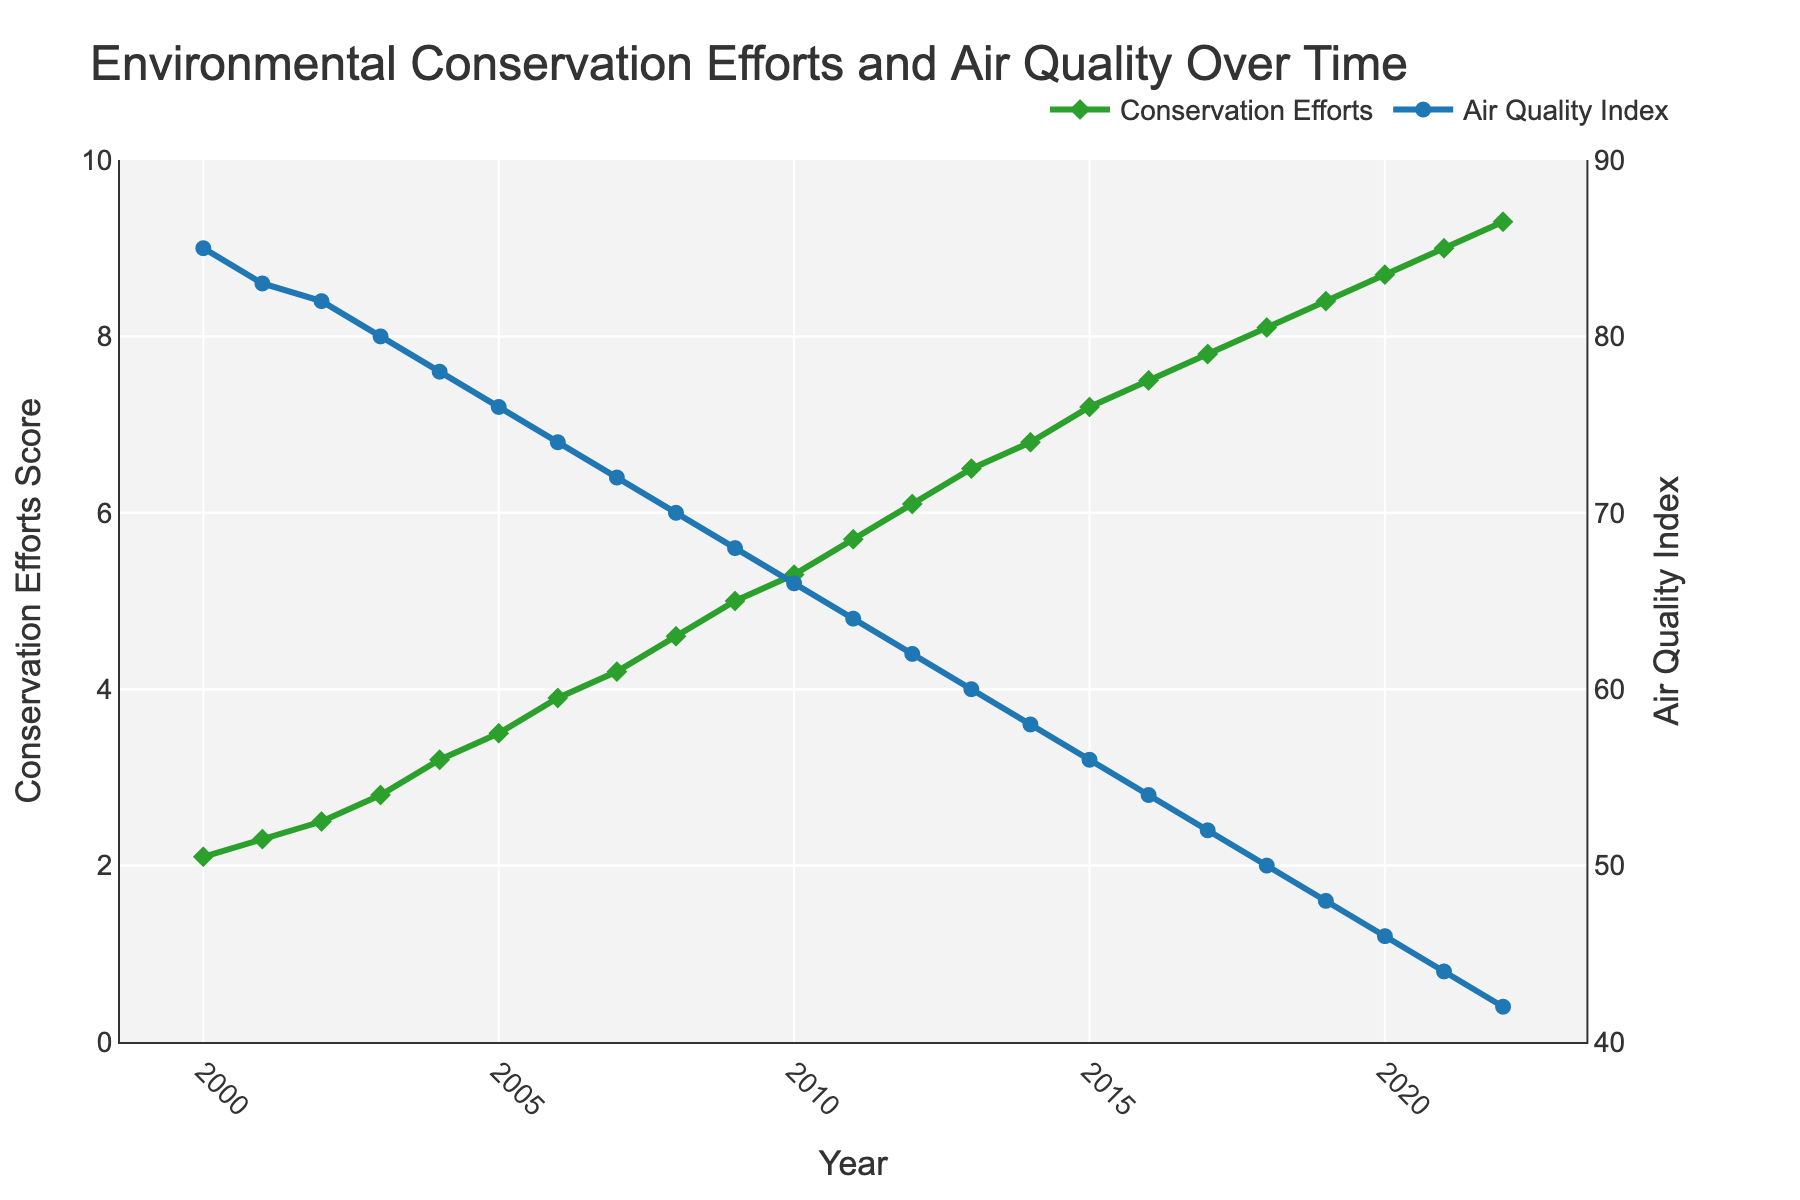What year did the conservation efforts score reach 7.0? The conservation efforts score reached 7.0 in the year 2015. We can see this by observing where the score curve intersects the 7.0 mark on the primary y-axis.
Answer: 2015 How has the air quality index changed from 2000 to 2005? In 2000, the air quality index was 85. By 2005, it had dropped to 76. The change can be calculated as 85 - 76 = 9. Thus, there was a decrease of 9 points in the air quality index.
Answer: Decreased by 9 points What is the trend between conservation efforts score and air quality index over time? The conservation efforts score shows an increasing trend over the years, while the air quality index shows a decreasing trend. These opposite trends suggest that as conservation efforts increased, the air quality improved (index decreased).
Answer: Increasing for conservation, decreasing for air quality Which year shows the greatest improvement in air quality index compared to the previous year? The greatest year-over-year improvement in air quality index appears between 2007 (72) and 2008 (70), with a decline of 2 points. This year shows the largest single-year drop in the index.
Answer: 2008 In what year did the conservation efforts score first surpass the halfway point between the lowest and highest observed scores (5.7)? The halfway point is calculated as (2.1 + 9.3) / 2 = 5.7. By looking at the plot, the year the conservation efforts score first surpasses 5.7 is 2011.
Answer: 2011 Compare the air quality index in 2000 and 2022. How much has the air quality improved? In 2000, the air quality index was 85. In 2022, it was 42. To calculate the improvement: 85 - 42 = 43. The air quality index improved by 43 points.
Answer: Improved by 43 points What is the shape and color of the markers used for the conservation efforts score line? The markers for the conservation efforts score line are diamond-shaped and green in color. This can be observed from the visual properties of the plot.
Answer: Diamond and green Describe the pattern of the air quality index from 2010 to 2015. From 2010 to 2015, the air quality index consistently decreased each year. In 2010, the index was 66 and by 2015 it had dropped to 56, showing a steady decline over the five-year period.
Answer: Consistently decreased What is the overall range of the conservation efforts score from 2000 to 2022? The conservation efforts score starts at 2.1 in 2000 and ends at 9.3 in 2022. The range can be calculated as 9.3 - 2.1 = 7.2.
Answer: 7.2 